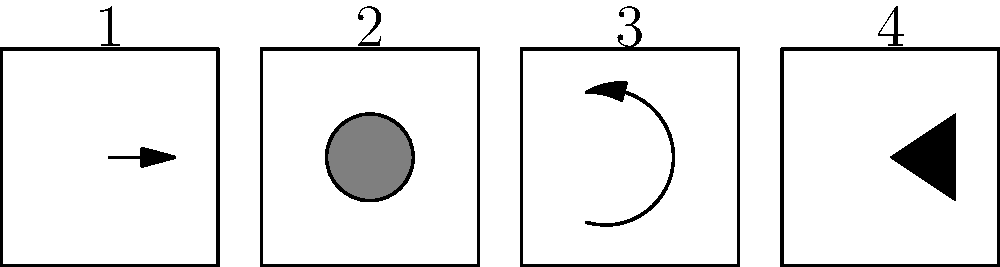Analyze the sequence of four panels above, which represents a wordless graphic novel sequence. Which visual storytelling technique is most prominently used to convey motion and direction across the panels? To answer this question, let's examine each panel and the visual elements used:

1. Panel 1: Contains a horizontal arrow pointing to the right.
2. Panel 2: Shows a circular shape in the center.
3. Panel 3: Displays a curved arrow moving from left to right.
4. Panel 4: Features a triangle shape pointing to the right.

Step-by-step analysis:
1. The question asks about conveying motion and direction across the panels.
2. The most consistent element across multiple panels is the use of shapes that imply rightward movement.
3. Panel 1 uses an explicit arrow pointing right.
4. Panel 3 also uses an arrow, but curved, still moving from left to right.
5. Panel 4 uses a triangular shape pointing to the right, similar to an arrowhead.
6. These elements, when viewed in sequence, create a sense of rightward motion.

The visual technique being used here is called "directional indicators." These are shapes, lines, or symbols that guide the reader's eye in a specific direction, implying motion and flow in a wordless sequence.
Answer: Directional indicators 